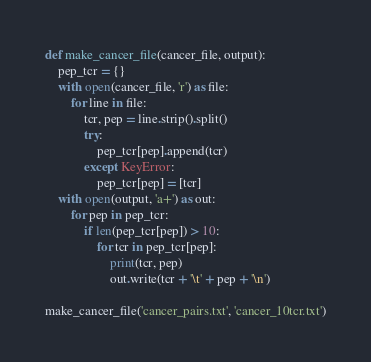<code> <loc_0><loc_0><loc_500><loc_500><_Python_>

def make_cancer_file(cancer_file, output):
    pep_tcr = {}
    with open(cancer_file, 'r') as file:
        for line in file:
            tcr, pep = line.strip().split()
            try:
                pep_tcr[pep].append(tcr)
            except KeyError:
                pep_tcr[pep] = [tcr]
    with open(output, 'a+') as out:
        for pep in pep_tcr:
            if len(pep_tcr[pep]) > 10:
                for tcr in pep_tcr[pep]:
                    print(tcr, pep)
                    out.write(tcr + '\t' + pep + '\n')

make_cancer_file('cancer_pairs.txt', 'cancer_10tcr.txt')</code> 